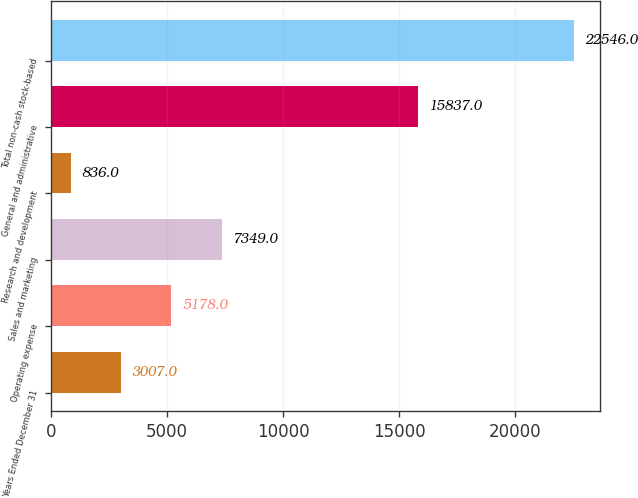Convert chart. <chart><loc_0><loc_0><loc_500><loc_500><bar_chart><fcel>Years Ended December 31<fcel>Operating expense<fcel>Sales and marketing<fcel>Research and development<fcel>General and administrative<fcel>Total non-cash stock-based<nl><fcel>3007<fcel>5178<fcel>7349<fcel>836<fcel>15837<fcel>22546<nl></chart> 